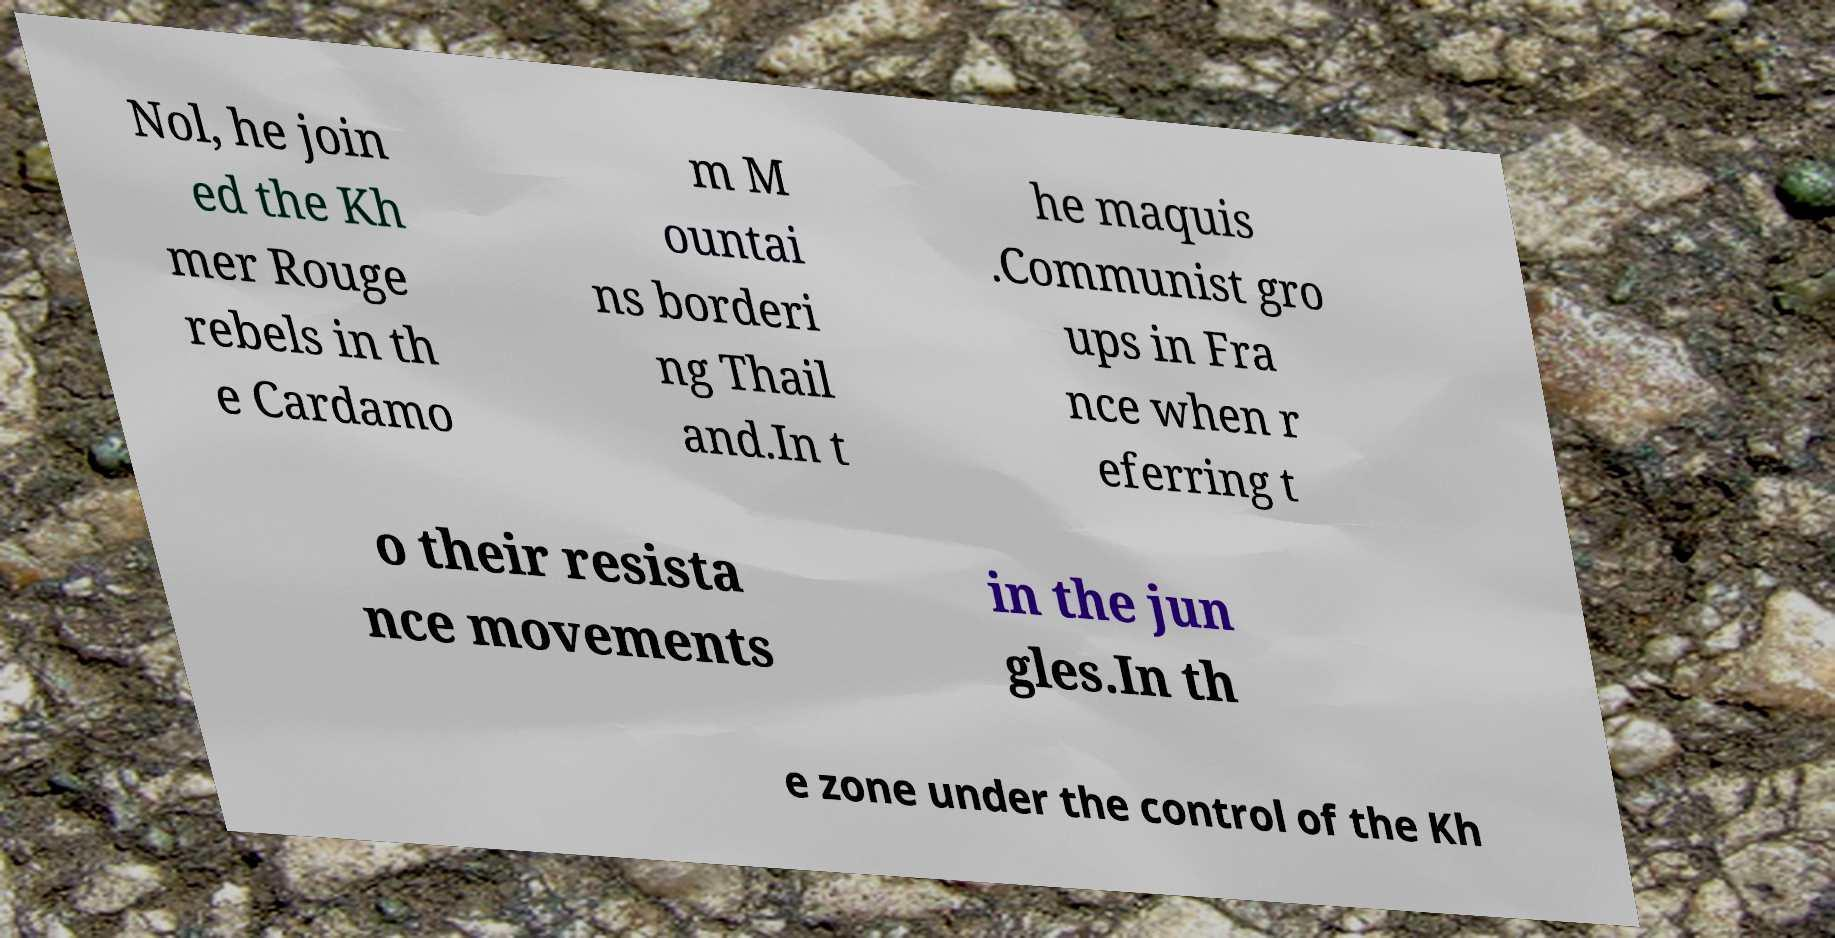I need the written content from this picture converted into text. Can you do that? Nol, he join ed the Kh mer Rouge rebels in th e Cardamo m M ountai ns borderi ng Thail and.In t he maquis .Communist gro ups in Fra nce when r eferring t o their resista nce movements in the jun gles.In th e zone under the control of the Kh 